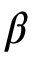Convert formula to latex. <formula><loc_0><loc_0><loc_500><loc_500>\beta</formula> 